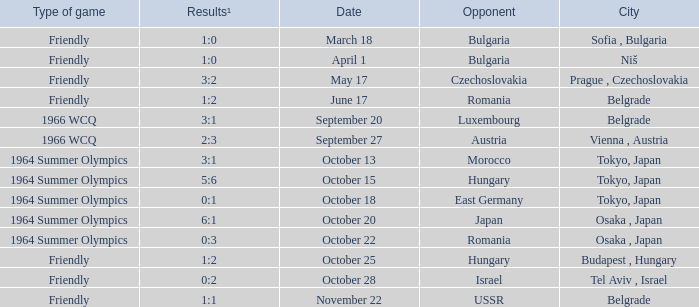Wjich city had a date of october 13? Tokyo, Japan. 